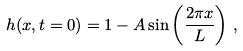<formula> <loc_0><loc_0><loc_500><loc_500>h ( x , t = 0 ) = 1 - A \sin \left ( \frac { 2 \pi x } { L } \right ) \, ,</formula> 